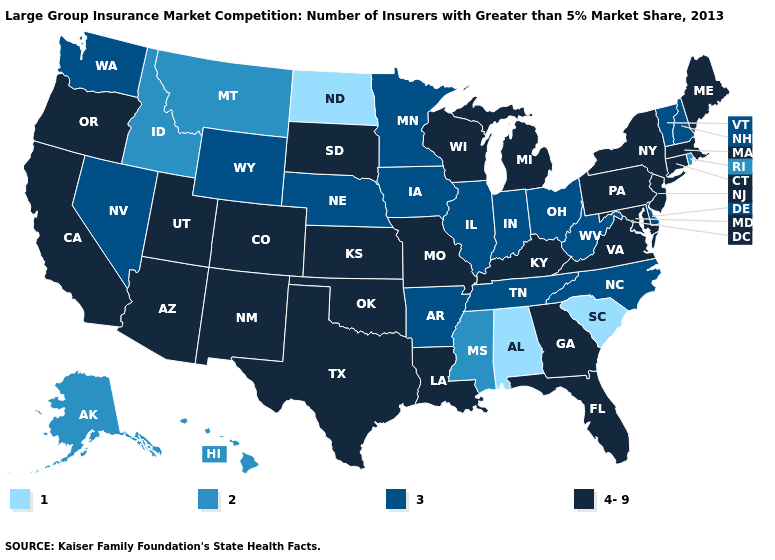Does the map have missing data?
Keep it brief. No. Among the states that border Maryland , which have the lowest value?
Answer briefly. Delaware, West Virginia. Name the states that have a value in the range 2?
Answer briefly. Alaska, Hawaii, Idaho, Mississippi, Montana, Rhode Island. What is the value of Virginia?
Keep it brief. 4-9. What is the value of North Carolina?
Short answer required. 3. Is the legend a continuous bar?
Keep it brief. No. What is the value of South Carolina?
Concise answer only. 1. What is the lowest value in the West?
Quick response, please. 2. Does the map have missing data?
Answer briefly. No. Name the states that have a value in the range 2?
Be succinct. Alaska, Hawaii, Idaho, Mississippi, Montana, Rhode Island. Which states have the lowest value in the USA?
Keep it brief. Alabama, North Dakota, South Carolina. Among the states that border California , does Nevada have the lowest value?
Give a very brief answer. Yes. Name the states that have a value in the range 1?
Short answer required. Alabama, North Dakota, South Carolina. Does the map have missing data?
Write a very short answer. No. What is the value of Arkansas?
Answer briefly. 3. 